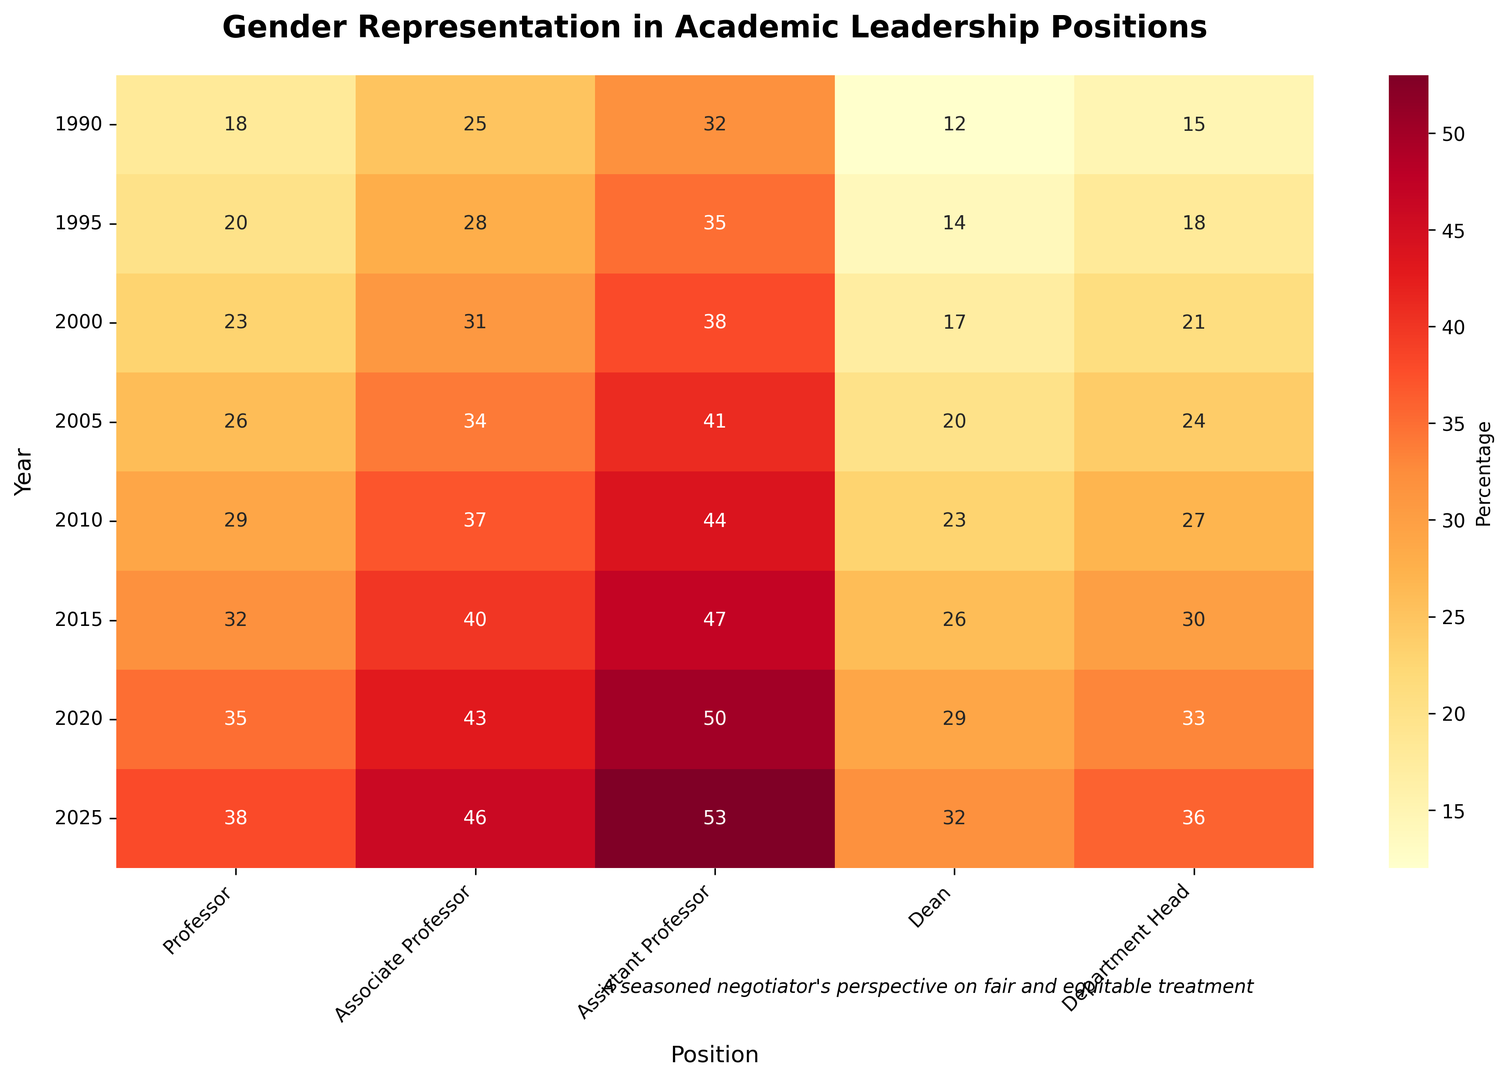What's the percentage of female professors in the year 2000? Locate the cell associated with the year 2000 and "Professor" in the heatmap. The cell value is 23.
Answer: 23 Which position had the highest increase in female representation from 1990 to 2025? Compare the percentages from 1990 and 2025 across all positions and calculate the differences: Professor (38-18=20), Associate Professor (46-25=21), Assistant Professor (53-32=21), Dean (32-12=20), Department Head (36-15=21). "Associate Professor," "Assistant Professor," and "Department Head" all had an increase of 21 percentage points.
Answer: Associate Professor, Assistant Professor, Department Head What's the average percentage of female representation across all positions in 2010? Sum the values of all positions in 2010 and divide by the number of positions: (29+37+44+23+27) / 5 = 160 / 5 = 32
Answer: 32 Which position had the least representation of females in 1995? Locate the year 1995 and identify the cell with the smallest number: Professor (20), Associate Professor (28), Assistant Professor (35), Dean (14), Department Head (18). "Dean" has the smallest value, 14.
Answer: Dean How much did the percentage of female deans increase from 2000 to 2020? Subtract the percentage in 2000 from the percentage in 2020: 29 - 17 = 12
Answer: 12 Which years had the highest and lowest total female representation across all positions, and what were those totals? Sum up the percentages for each year, then compare: 1990 (102), 1995 (115), 2000 (130), 2005 (145), 2010 (160), 2015 (175), 2020 (190), 2025 (205). The highest total is 205 in 2025, and the lowest total is 102 in 1990.
Answer: Highest: 2025, Lowest: 1990 What’s the trend of female representation in the position "Department Head" from 1990 to 2025? Observe the increasing values over time for the "Department Head" row: 1990 (15), 1995 (18), 2000 (21), 2005 (24), 2010 (27), 2015 (30), 2020 (33), 2025 (36). The trend shows a consistent increase.
Answer: Increasing What's the median percentage of female representation for the "Assistant Professor" position from 1990 to 2025? Order the values for "Assistant Professor": 32, 35, 38, 41, 44, 47, 50, 53. The median is the average of the 4th and 5th values: (41+44)/2 = 42.5
Answer: 42.5 What's the difference in female representation between "Professor" and "Assistant Professor" in 2015? Subtract the percentage of "Professor" from that of "Assistant Professor" in 2015: 47 - 32 = 15
Answer: 15 Which position shows the most significant change in female representation from 2005 to 2015? Calculate the differences: Professor (32-26=6), Associate Professor (40-34=6), Assistant Professor (47-41=6), Dean (26-20=6), Department Head (30-24=6). All positions exhibit an equal change of 6 percentage points.
Answer: All positions (equal) 